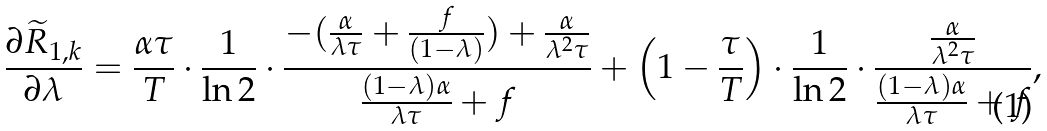Convert formula to latex. <formula><loc_0><loc_0><loc_500><loc_500>\frac { \partial \widetilde { R } _ { 1 , k } } { \partial \lambda } = \frac { \alpha \tau } { T } \cdot \frac { 1 } { \ln 2 } \cdot \frac { - ( \frac { \alpha } { \lambda \tau } + \frac { f } { ( 1 - \lambda ) } ) + \frac { \alpha } { \lambda ^ { 2 } \tau } } { \frac { ( 1 - \lambda ) \alpha } { \lambda \tau } + f } + \left ( 1 - \frac { \tau } { T } \right ) \cdot \frac { 1 } { \ln 2 } \cdot \frac { \frac { \alpha } { \lambda ^ { 2 } \tau } } { \frac { ( 1 - \lambda ) \alpha } { \lambda \tau } + f } ,</formula> 